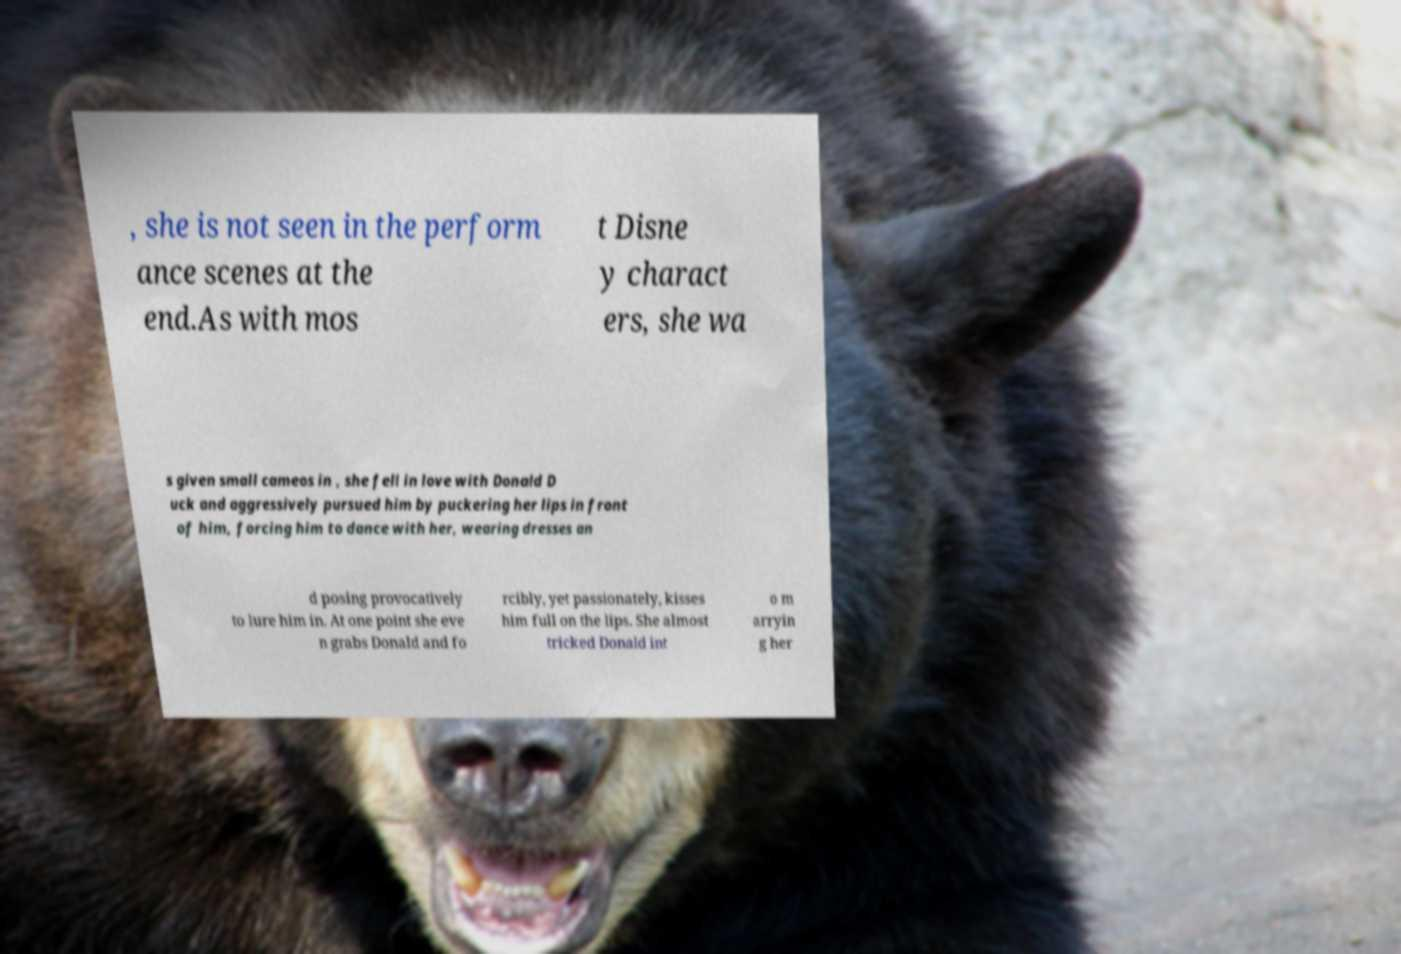Can you accurately transcribe the text from the provided image for me? , she is not seen in the perform ance scenes at the end.As with mos t Disne y charact ers, she wa s given small cameos in , she fell in love with Donald D uck and aggressively pursued him by puckering her lips in front of him, forcing him to dance with her, wearing dresses an d posing provocatively to lure him in. At one point she eve n grabs Donald and fo rcibly, yet passionately, kisses him full on the lips. She almost tricked Donald int o m arryin g her 